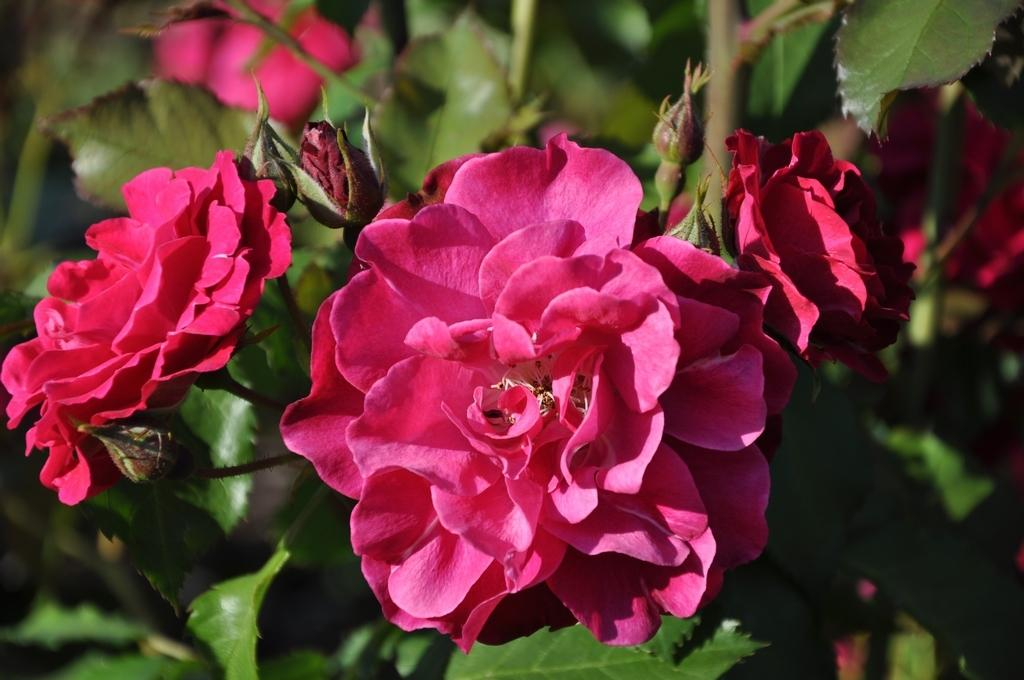What type of plant life can be seen in the image? There are flowers and leaves in the image. Can you describe the flowers in the image? Unfortunately, the facts provided do not give specific details about the flowers. How many different types of leaves are visible in the image? The facts provided do not specify the number of different types of leaves. What arithmetic problem is being solved on the leaf in the image? There is no arithmetic problem visible on the leaf in the image. What type of experience can be gained from observing the flowers in the image? The facts provided do not give any information about the potential experiences that can be gained from observing the flowers. 